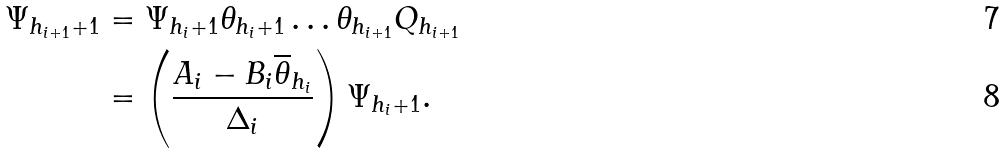<formula> <loc_0><loc_0><loc_500><loc_500>\Psi _ { h _ { i + 1 } + 1 } & = \Psi _ { h _ { i } + 1 } \theta _ { h _ { i } + 1 } \dots \theta _ { h _ { i + 1 } } Q _ { h _ { i + 1 } } \\ & = \left ( \frac { A _ { i } - B _ { i } \overline { \theta } _ { h _ { i } } } { \Delta _ { i } } \right ) \Psi _ { h _ { i } + 1 } .</formula> 